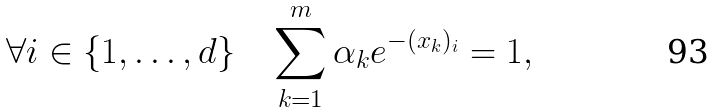Convert formula to latex. <formula><loc_0><loc_0><loc_500><loc_500>\forall i \in \{ 1 , \dots , d \} \quad \sum _ { k = 1 } ^ { m } \alpha _ { k } e ^ { - ( x _ { k } ) _ { i } } = 1 ,</formula> 